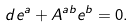Convert formula to latex. <formula><loc_0><loc_0><loc_500><loc_500>d e ^ { a } + A ^ { a b } e ^ { b } = 0 .</formula> 